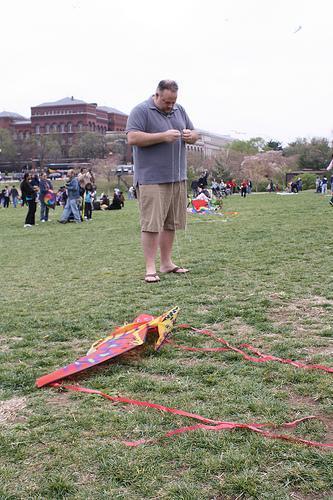How many kites are this picture?
Give a very brief answer. 1. 